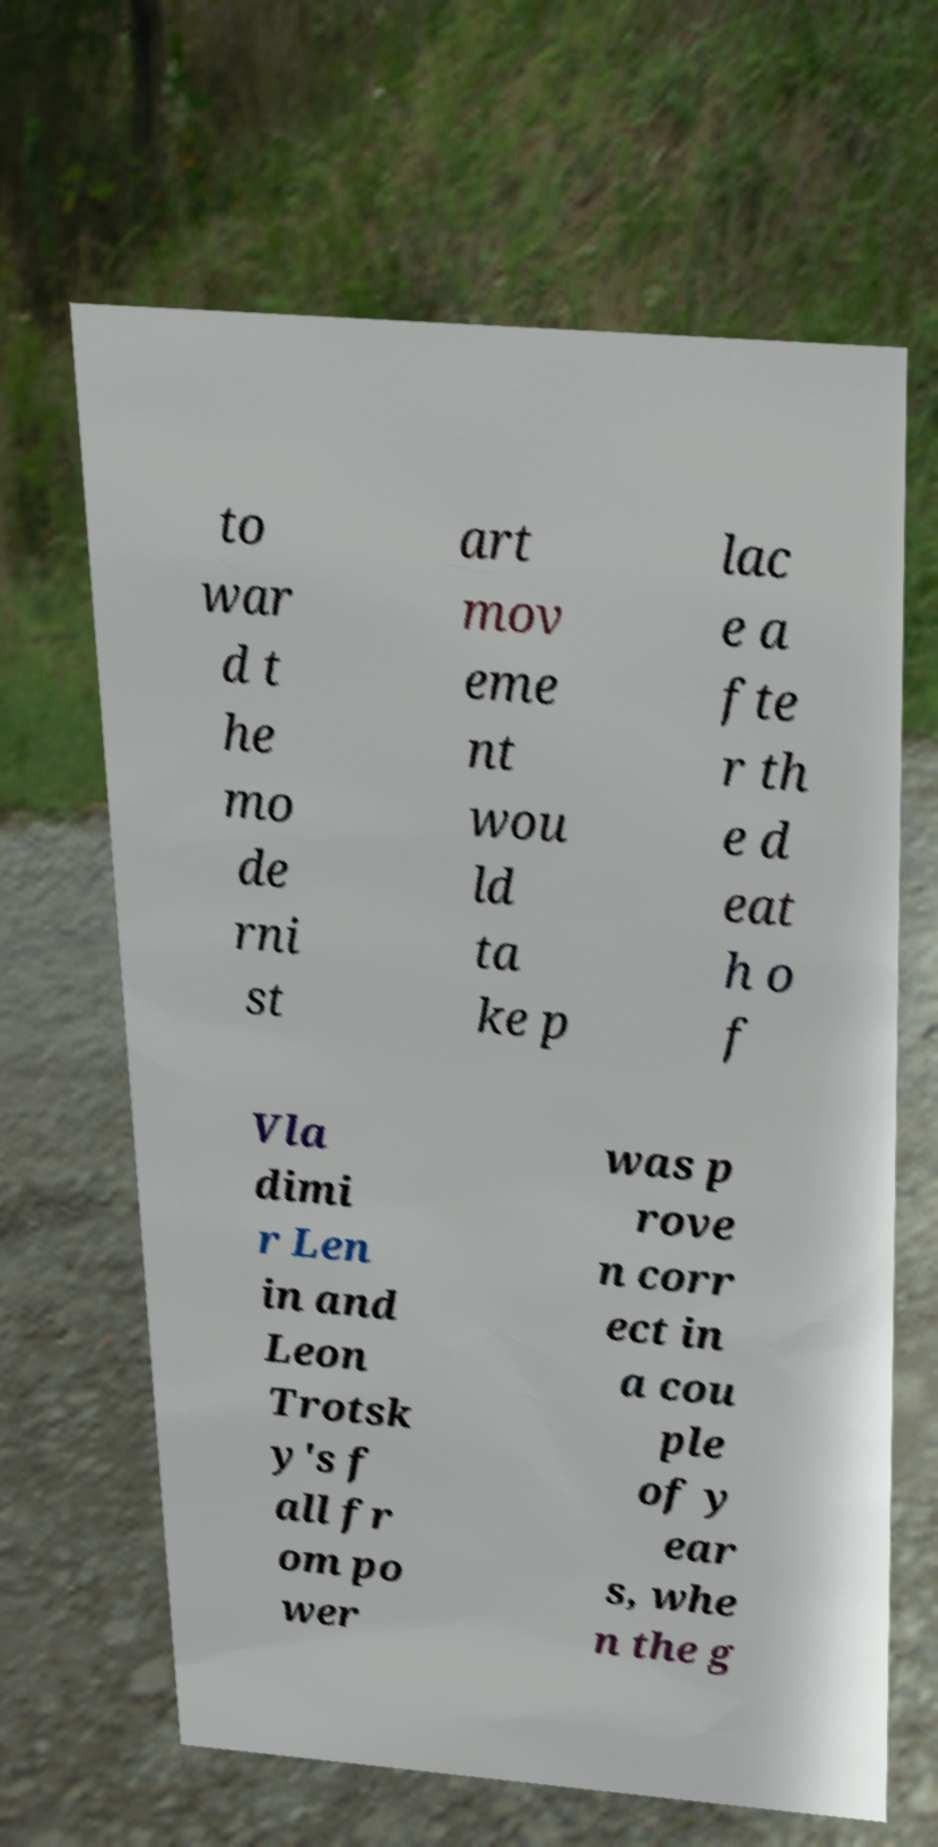I need the written content from this picture converted into text. Can you do that? to war d t he mo de rni st art mov eme nt wou ld ta ke p lac e a fte r th e d eat h o f Vla dimi r Len in and Leon Trotsk y's f all fr om po wer was p rove n corr ect in a cou ple of y ear s, whe n the g 